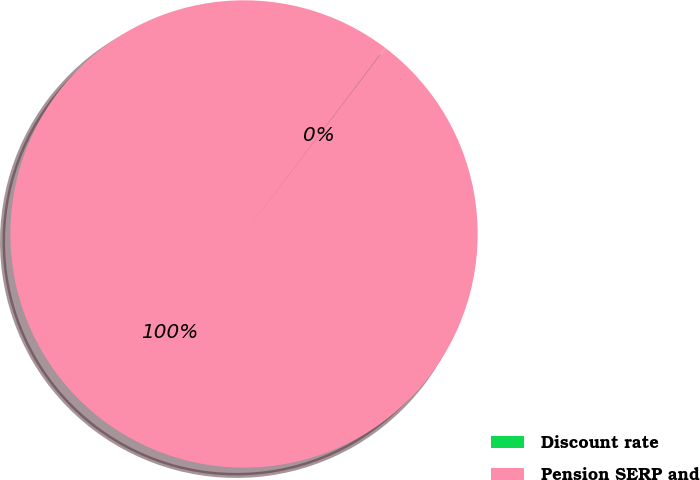Convert chart to OTSL. <chart><loc_0><loc_0><loc_500><loc_500><pie_chart><fcel>Discount rate<fcel>Pension SERP and<nl><fcel>0.02%<fcel>99.98%<nl></chart> 